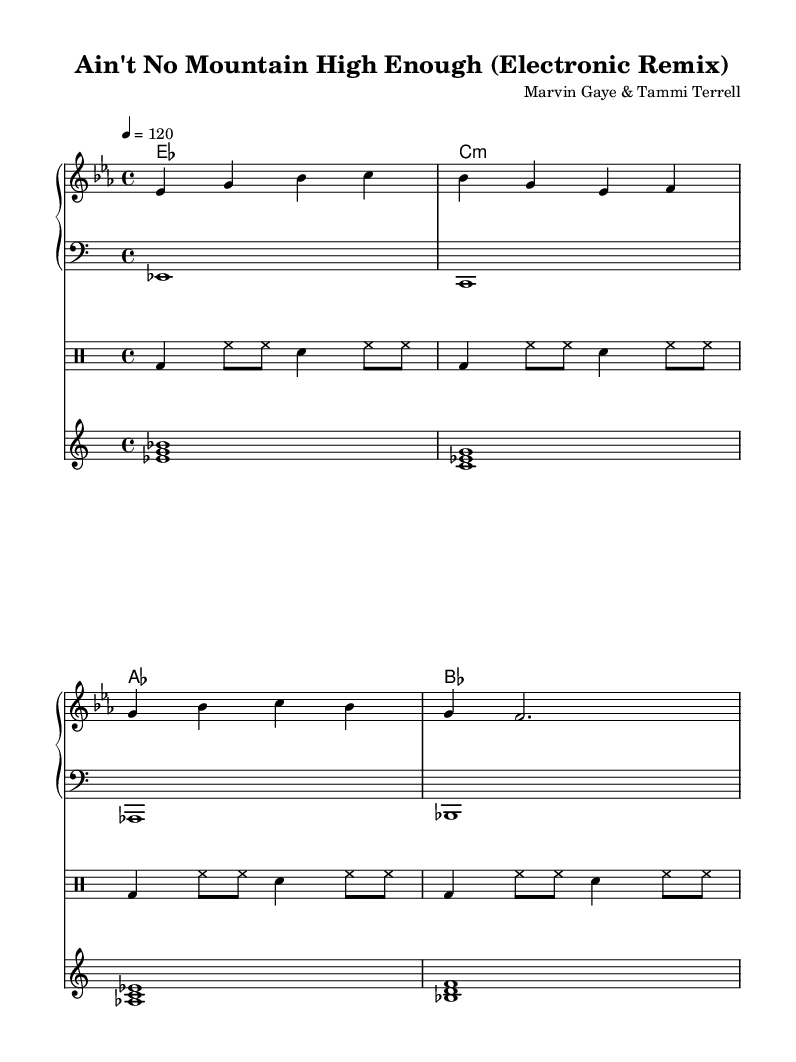What is the key signature of this music? The key signature is E-flat major, indicated by the two flats (B-flat and E-flat) shown at the beginning of the staff.
Answer: E-flat major What is the time signature of the piece? The time signature is 4/4, as displayed at the beginning of the sheet music, indicating four beats per measure.
Answer: 4/4 What is the tempo marking for this arrangement? The tempo is marked as a quarter note equals 120 beats per minute, shown in the tempo indication at the start of the score.
Answer: 120 How many bars are there in the melody section shown? By counting the individual measures in the melody line, there are a total of eight bars presented.
Answer: Eight Which instrument plays the bass line? The bass line is indicated with a bass clef, suggesting that the lower part is designed for a bass instrument, such as a bass guitar or electric bass.
Answer: Bass Identify the type of percussion used in this arrangement. The drum section includes bass drum and snare drum patterns, along with hi-hats, typical of most electronic and modern music productions.
Answer: Electronic drums What chord progression is featured in the harmonies? The chord progression includes the chords E-flat, C minor, A-flat, and B-flat, which are common in Motown-style songs.
Answer: E-flat, C minor, A-flat, B-flat 